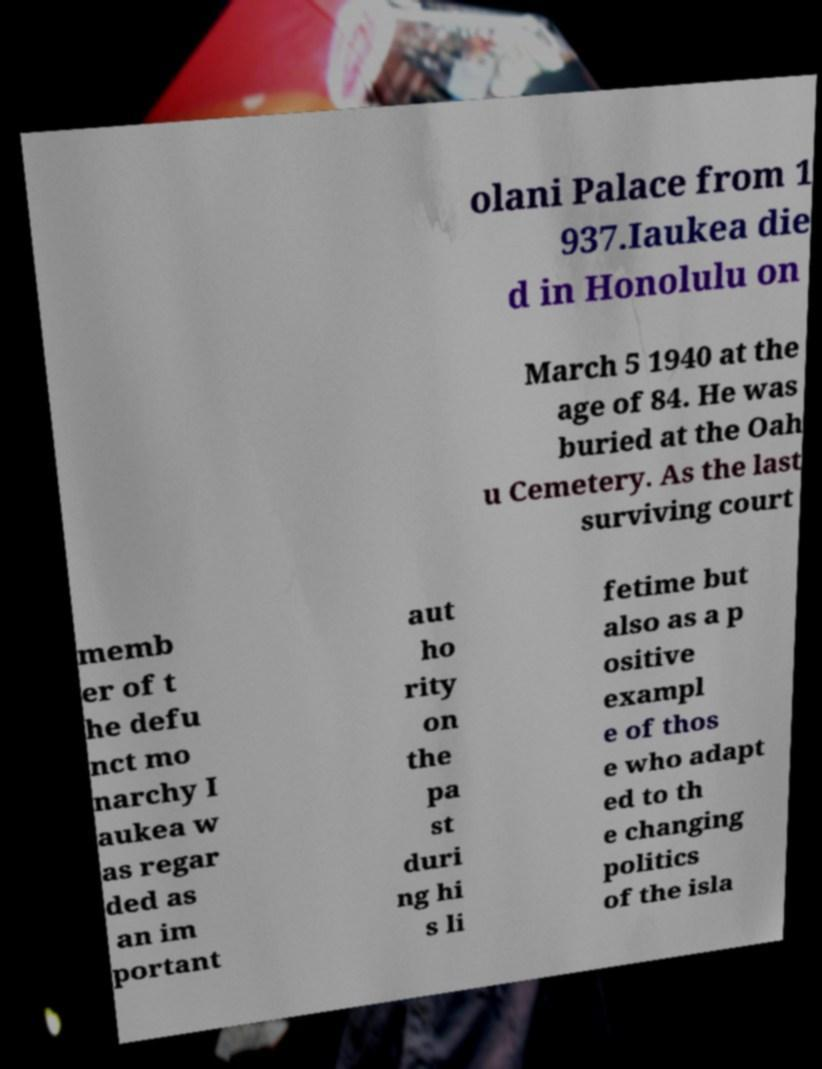Can you read and provide the text displayed in the image?This photo seems to have some interesting text. Can you extract and type it out for me? olani Palace from 1 937.Iaukea die d in Honolulu on March 5 1940 at the age of 84. He was buried at the Oah u Cemetery. As the last surviving court memb er of t he defu nct mo narchy I aukea w as regar ded as an im portant aut ho rity on the pa st duri ng hi s li fetime but also as a p ositive exampl e of thos e who adapt ed to th e changing politics of the isla 